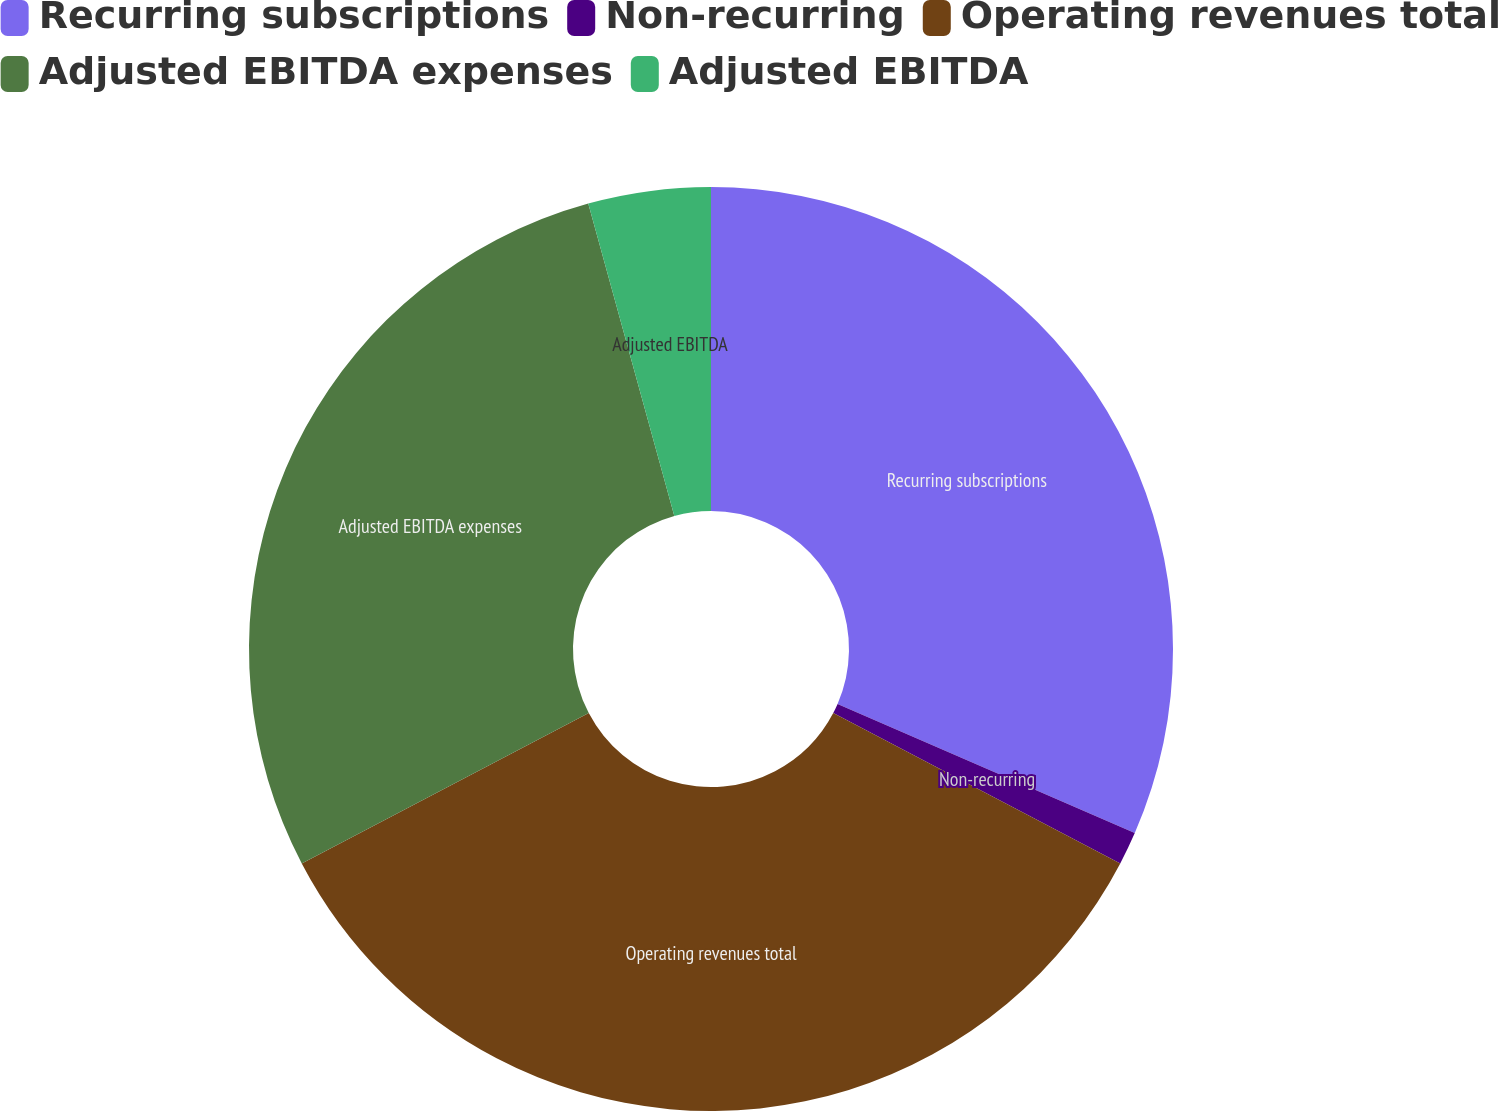<chart> <loc_0><loc_0><loc_500><loc_500><pie_chart><fcel>Recurring subscriptions<fcel>Non-recurring<fcel>Operating revenues total<fcel>Adjusted EBITDA expenses<fcel>Adjusted EBITDA<nl><fcel>31.52%<fcel>1.16%<fcel>34.64%<fcel>28.4%<fcel>4.28%<nl></chart> 